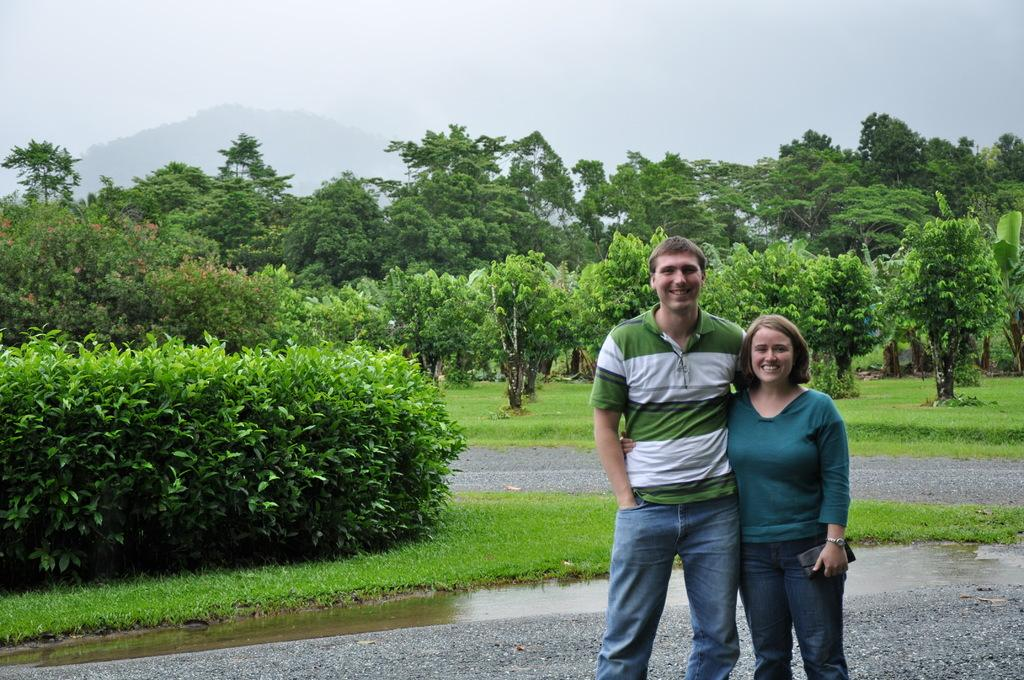How many people are present in the image? There are two people standing in the image. What are the people doing in the image? The people are posing for a photo. What can be seen in the background of the image? There are many trees, plants, and a grass surface in the background of the image. What type of oil can be seen dripping from the eyes of the people in the image? There is no oil or any dripping substance visible in the eyes of the people in the image. 